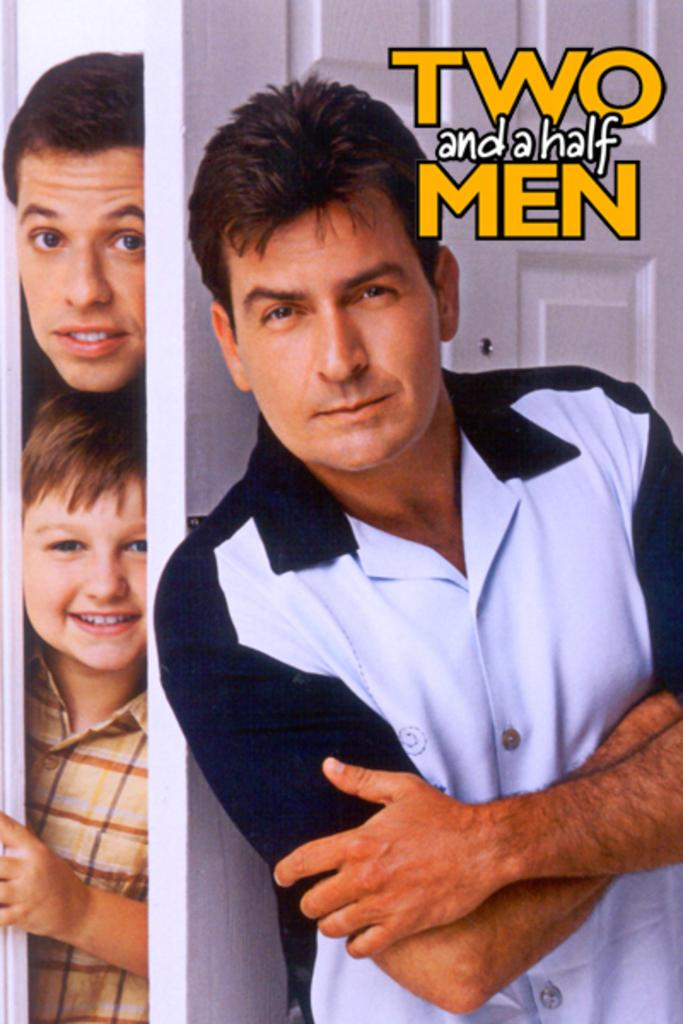What type of visual is depicted in the image? The image is a poster. Who is featured in the image? There is a man standing in the image. Can you describe the scene on the left side of the image? There are two people behind a door on the left side of the image. What is written or displayed at the top of the image? There is text at the top of the image. What organization does the fireman represent in the image? There is no fireman present in the image. How many pages are visible in the image? The image is a poster, not a book or document, so there are no pages visible. 